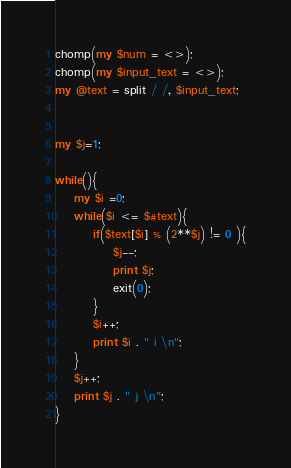<code> <loc_0><loc_0><loc_500><loc_500><_Perl_>chomp(my $num = <>);
chomp(my $input_text = <>);
my @text = split / /, $input_text;


my $j=1;

while(){
    my $i =0;
    while($i <= $#text){
        if($text[$i] % (2**$j) != 0 ){
            $j--;
            print $j;
            exit(0);
        }
        $i++;
        print $i . " i \n";
    }
    $j++;
    print $j . " j \n";
}
</code> 